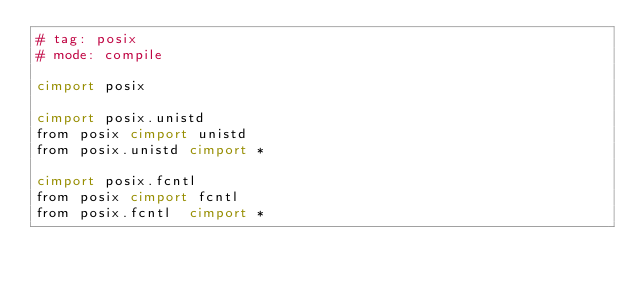<code> <loc_0><loc_0><loc_500><loc_500><_Cython_># tag: posix
# mode: compile

cimport posix

cimport posix.unistd
from posix cimport unistd
from posix.unistd cimport *

cimport posix.fcntl
from posix cimport fcntl
from posix.fcntl  cimport *
</code> 